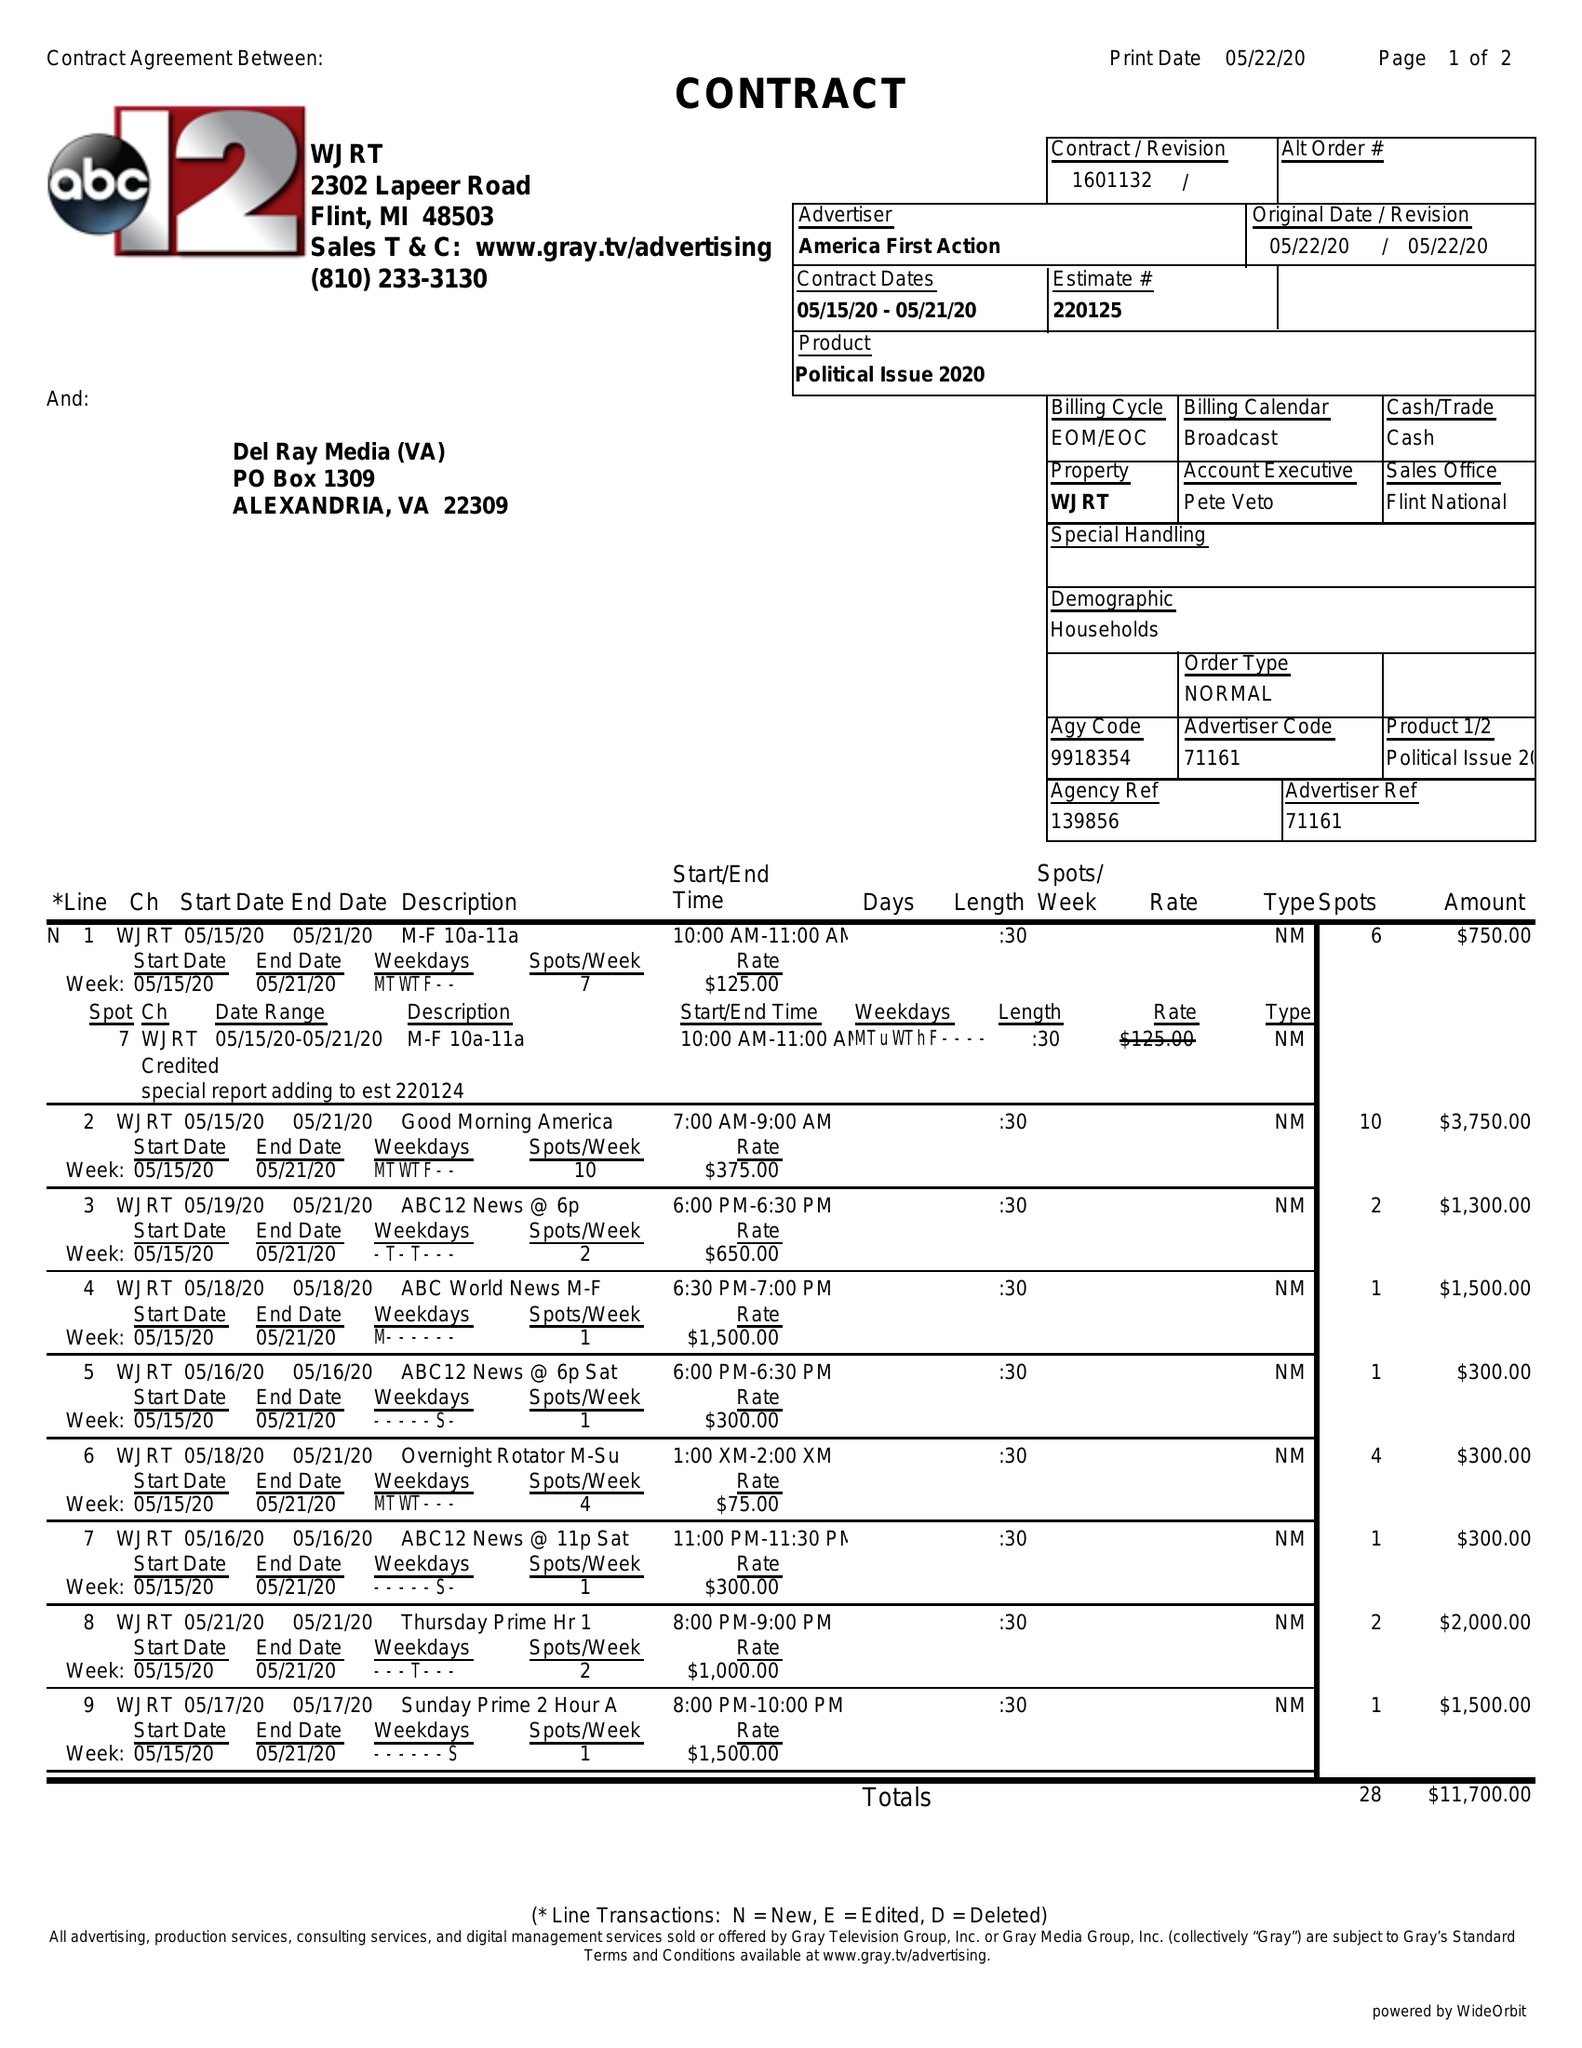What is the value for the gross_amount?
Answer the question using a single word or phrase. 11700.00 